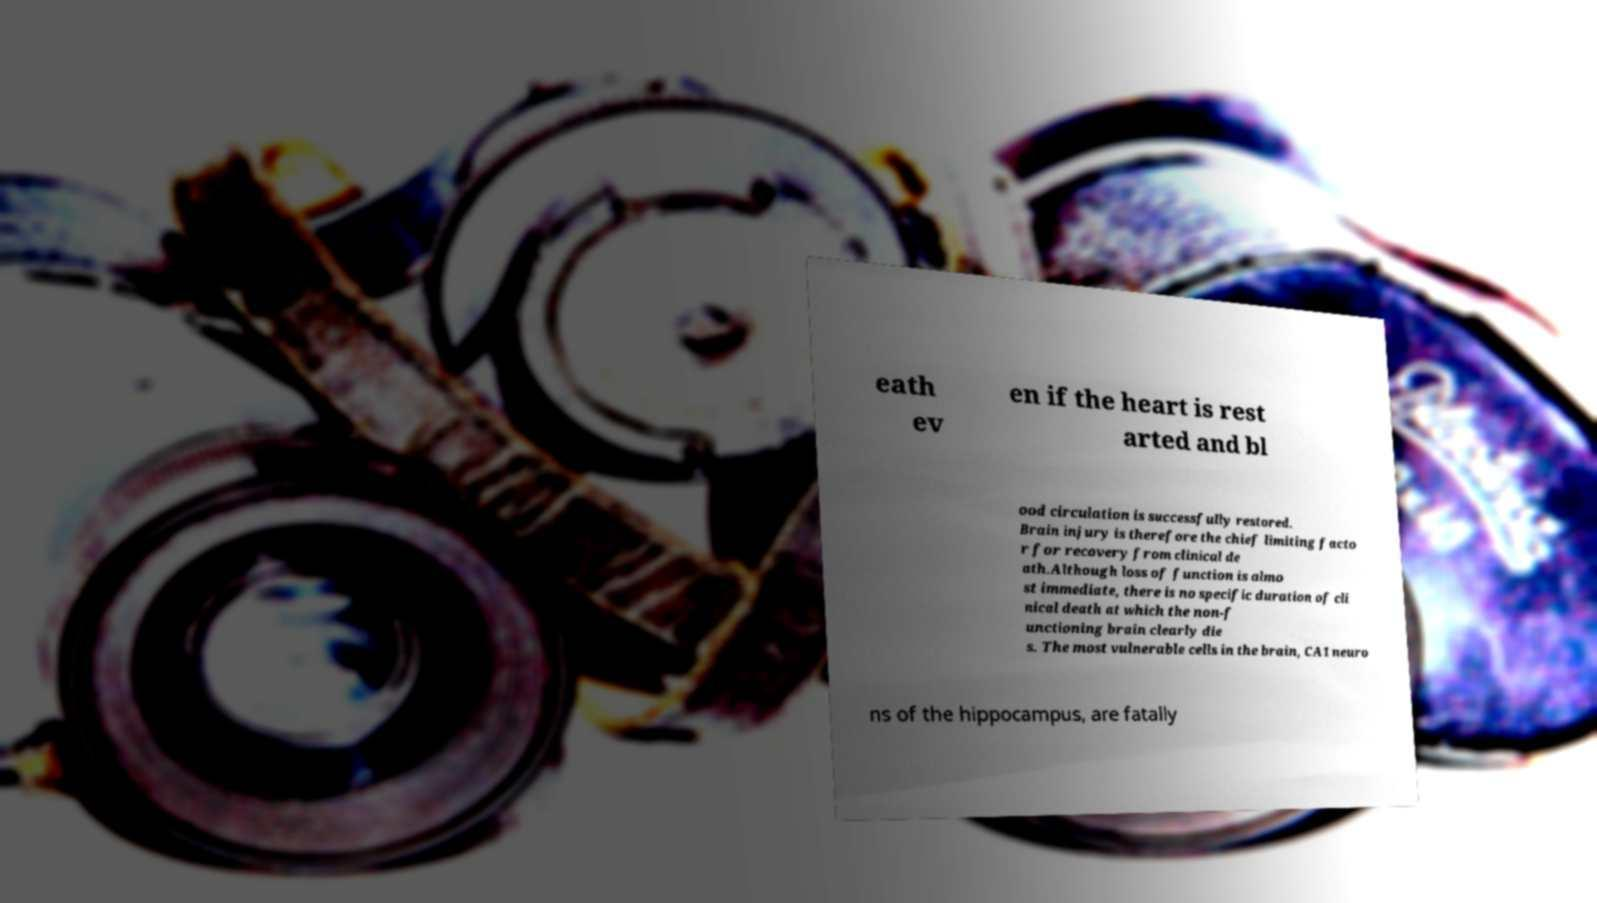Can you read and provide the text displayed in the image?This photo seems to have some interesting text. Can you extract and type it out for me? eath ev en if the heart is rest arted and bl ood circulation is successfully restored. Brain injury is therefore the chief limiting facto r for recovery from clinical de ath.Although loss of function is almo st immediate, there is no specific duration of cli nical death at which the non-f unctioning brain clearly die s. The most vulnerable cells in the brain, CA1 neuro ns of the hippocampus, are fatally 